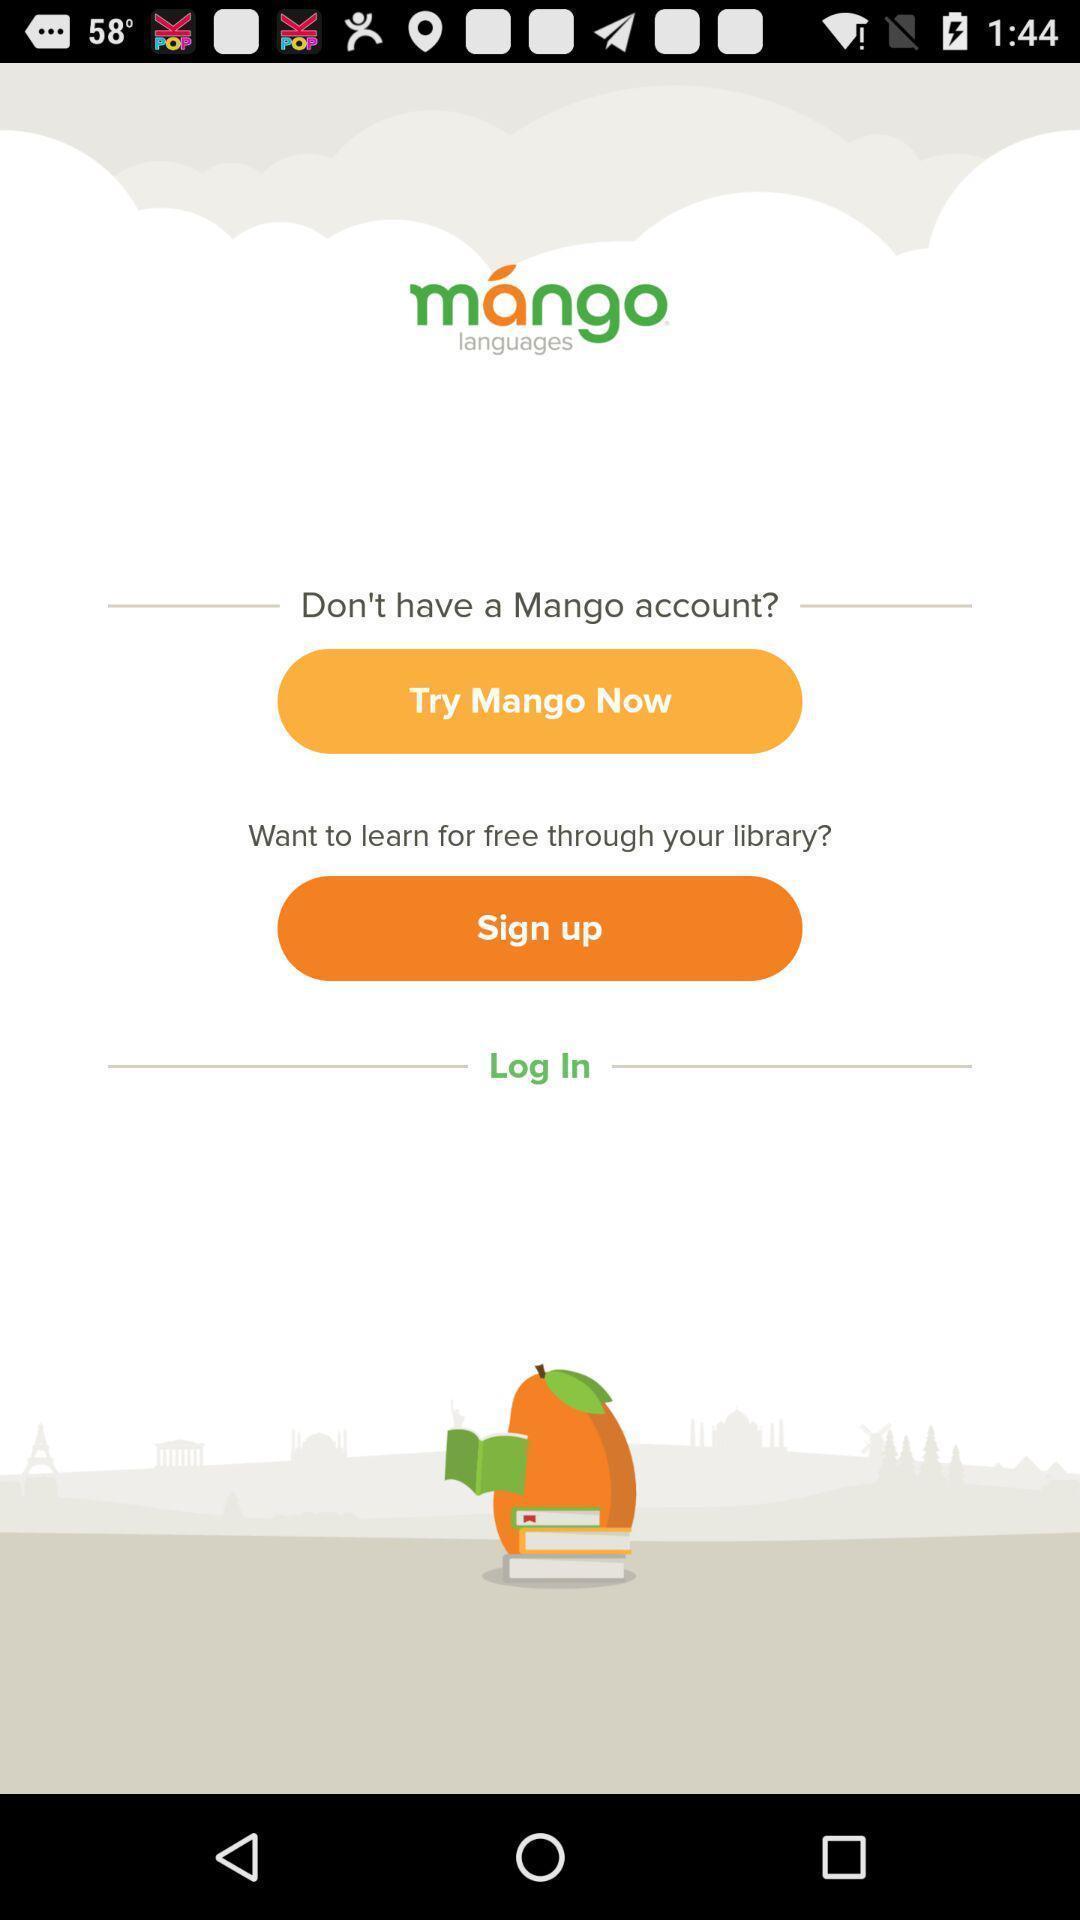Tell me about the visual elements in this screen capture. Welcome page for a language learning app. 